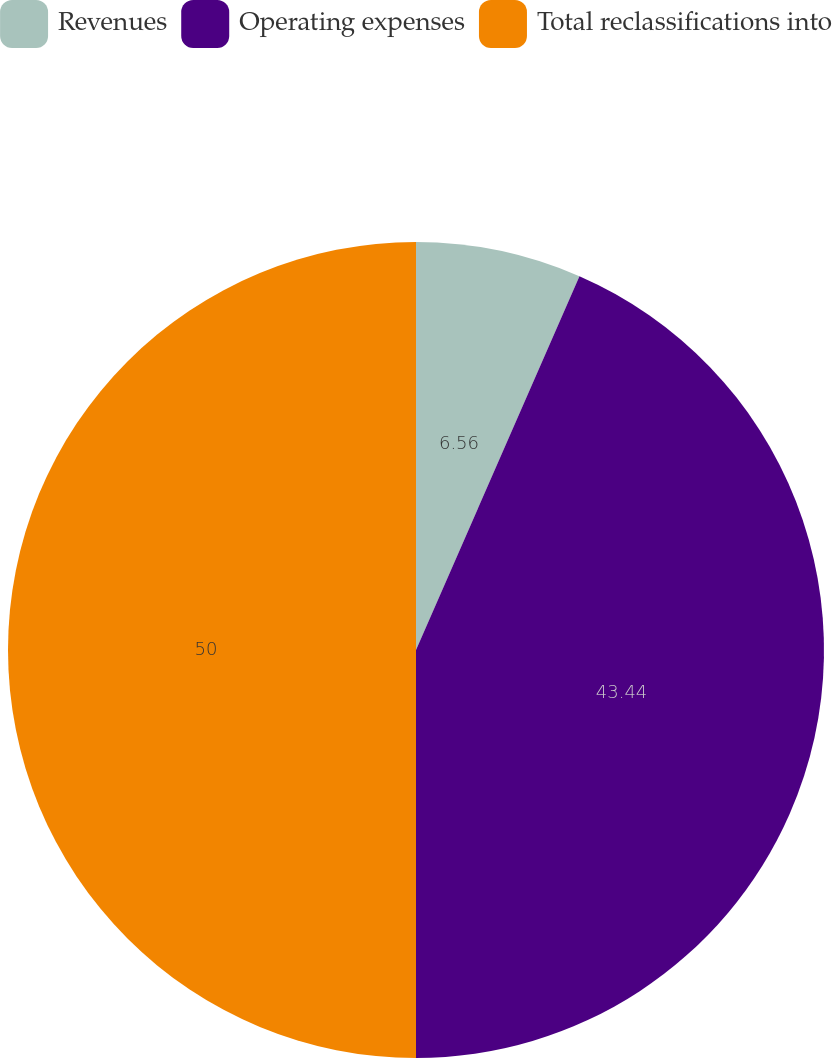<chart> <loc_0><loc_0><loc_500><loc_500><pie_chart><fcel>Revenues<fcel>Operating expenses<fcel>Total reclassifications into<nl><fcel>6.56%<fcel>43.44%<fcel>50.0%<nl></chart> 